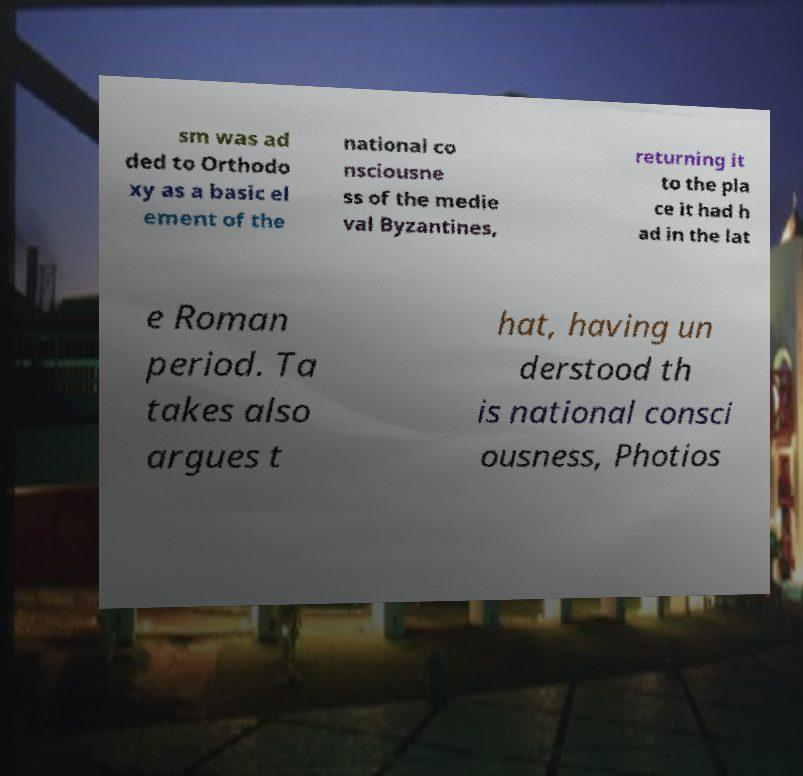Can you accurately transcribe the text from the provided image for me? sm was ad ded to Orthodo xy as a basic el ement of the national co nsciousne ss of the medie val Byzantines, returning it to the pla ce it had h ad in the lat e Roman period. Ta takes also argues t hat, having un derstood th is national consci ousness, Photios 